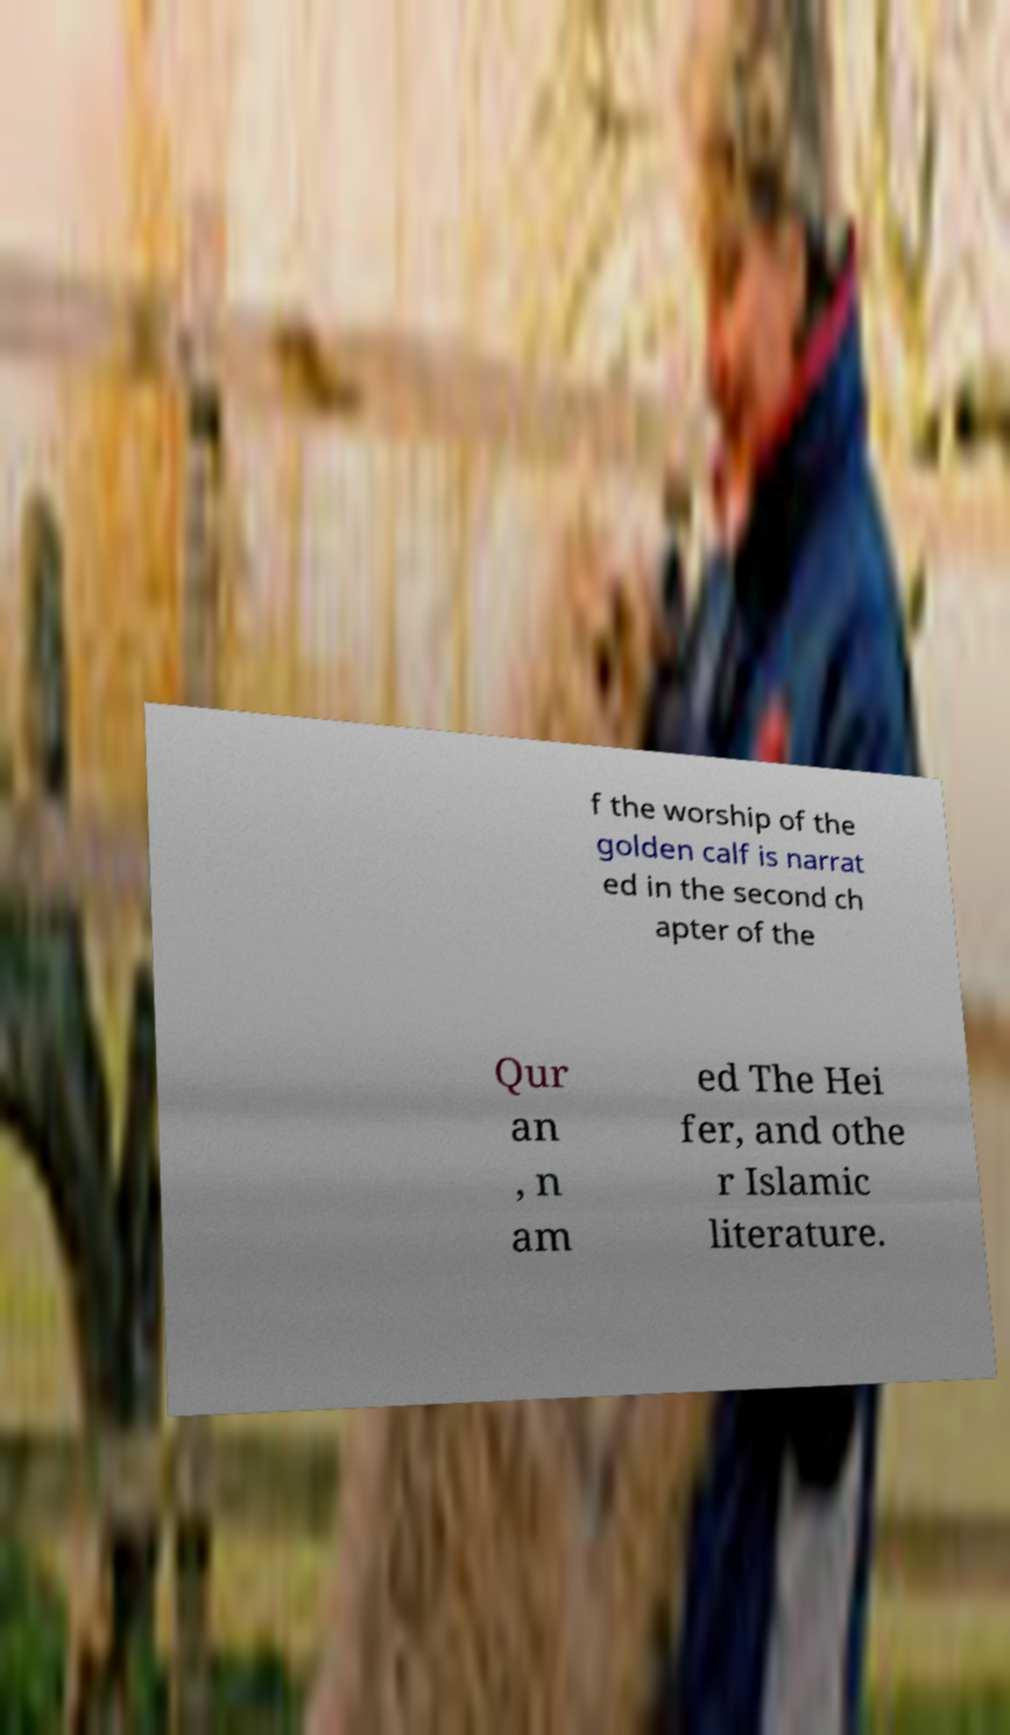For documentation purposes, I need the text within this image transcribed. Could you provide that? f the worship of the golden calf is narrat ed in the second ch apter of the Qur an , n am ed The Hei fer, and othe r Islamic literature. 